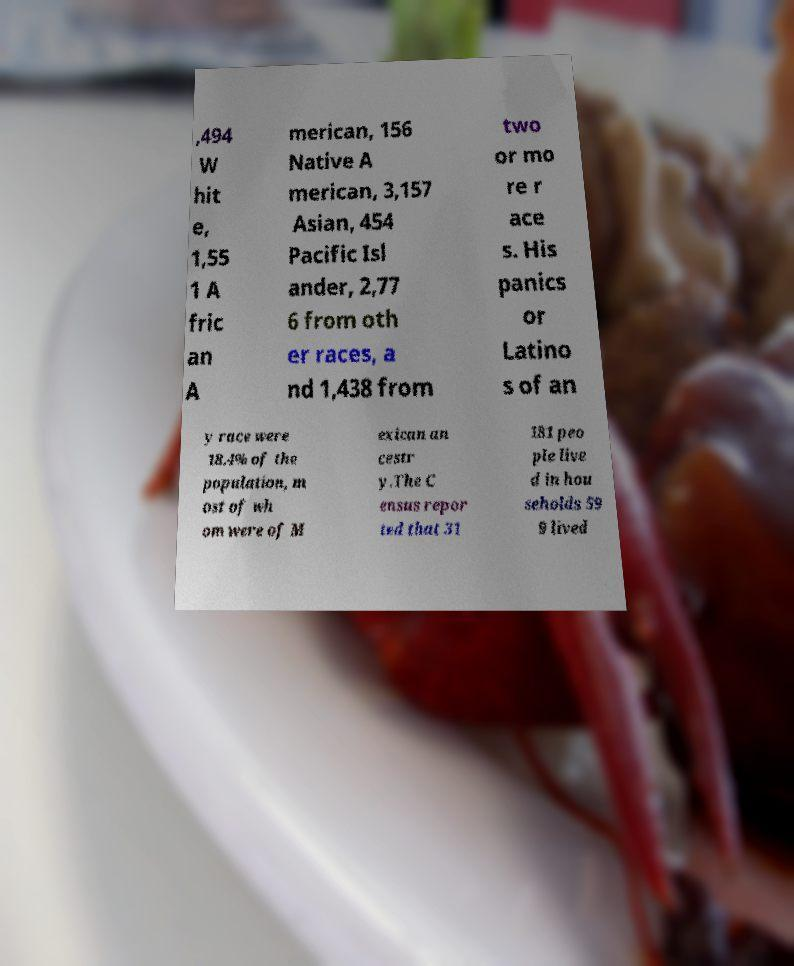What messages or text are displayed in this image? I need them in a readable, typed format. ,494 W hit e, 1,55 1 A fric an A merican, 156 Native A merican, 3,157 Asian, 454 Pacific Isl ander, 2,77 6 from oth er races, a nd 1,438 from two or mo re r ace s. His panics or Latino s of an y race were 18.4% of the population, m ost of wh om were of M exican an cestr y.The C ensus repor ted that 31 181 peo ple live d in hou seholds 59 9 lived 